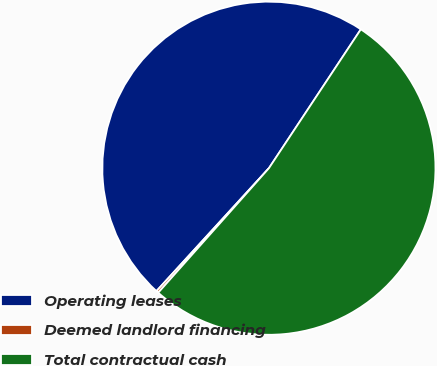Convert chart to OTSL. <chart><loc_0><loc_0><loc_500><loc_500><pie_chart><fcel>Operating leases<fcel>Deemed landlord financing<fcel>Total contractual cash<nl><fcel>47.51%<fcel>0.23%<fcel>52.26%<nl></chart> 